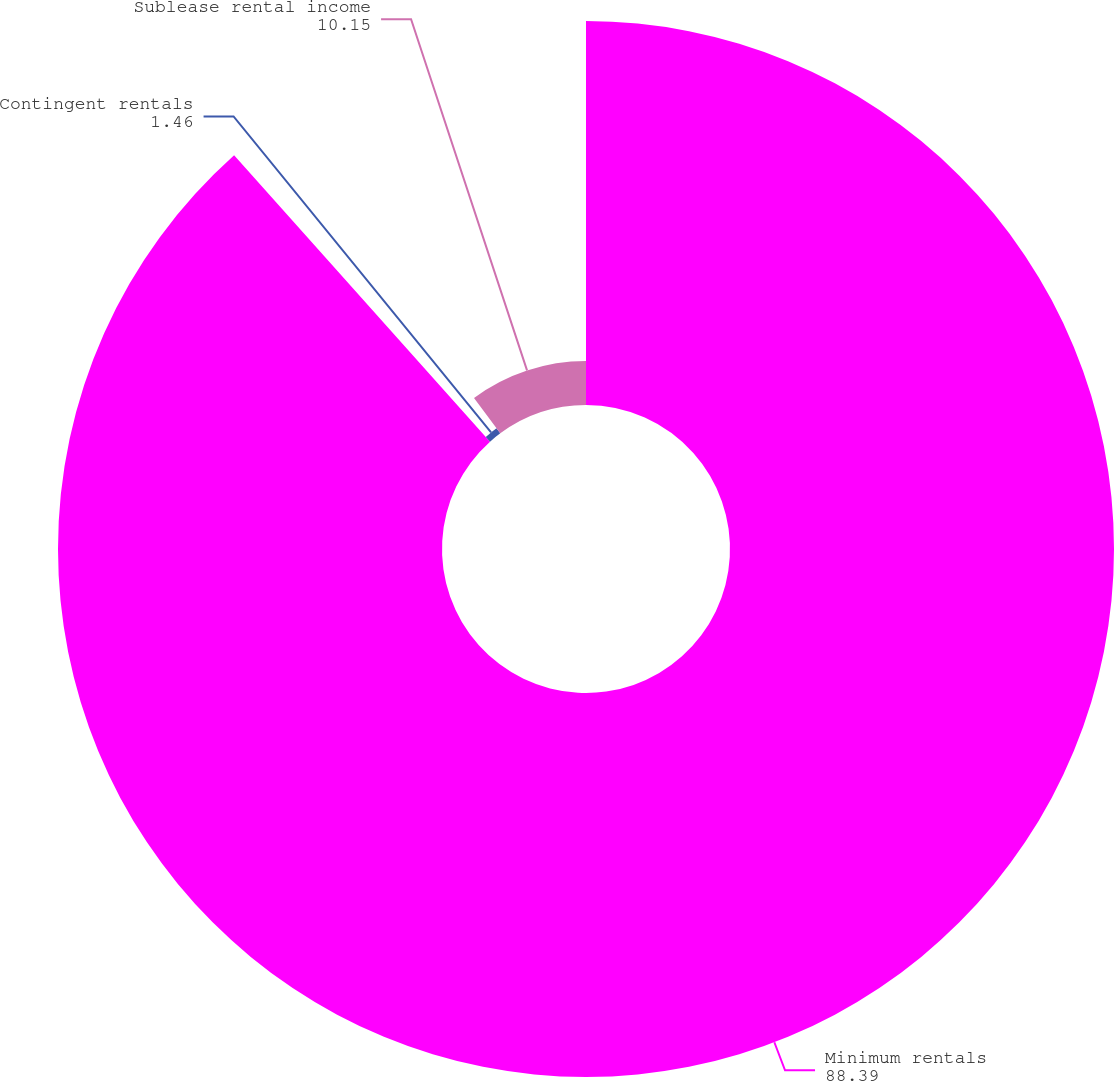Convert chart. <chart><loc_0><loc_0><loc_500><loc_500><pie_chart><fcel>Minimum rentals<fcel>Contingent rentals<fcel>Sublease rental income<nl><fcel>88.39%<fcel>1.46%<fcel>10.15%<nl></chart> 